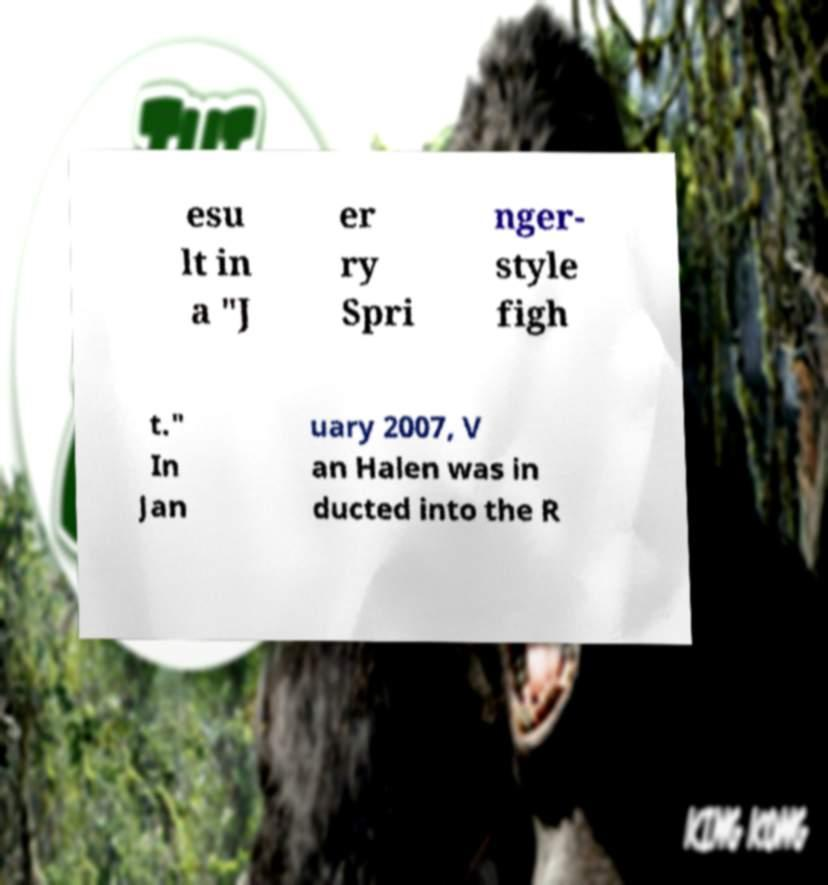Could you assist in decoding the text presented in this image and type it out clearly? esu lt in a "J er ry Spri nger- style figh t." In Jan uary 2007, V an Halen was in ducted into the R 